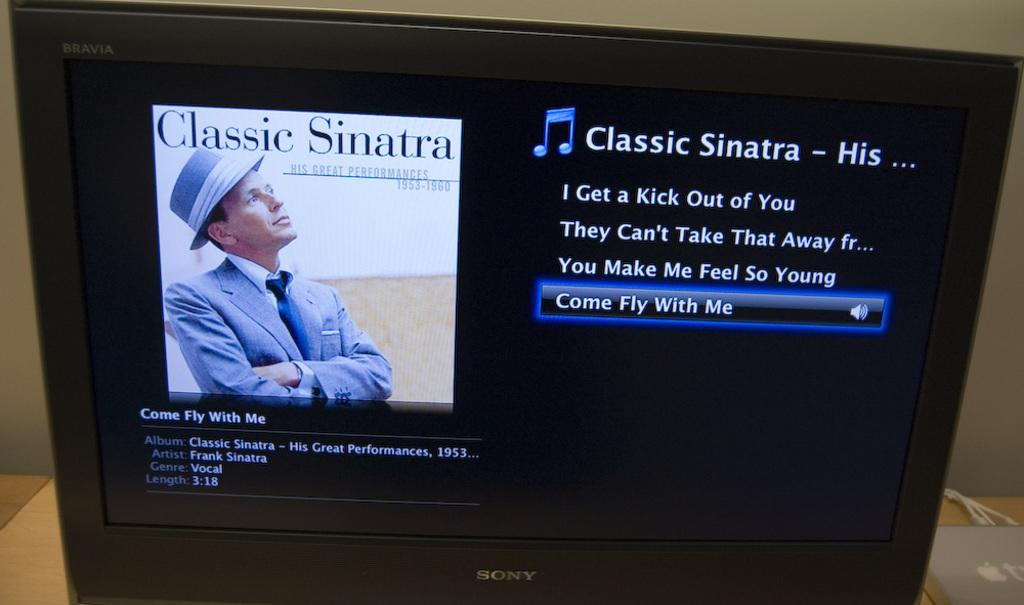<image>
Create a compact narrative representing the image presented. A Sony TV showing the Classic Sinatra album. 